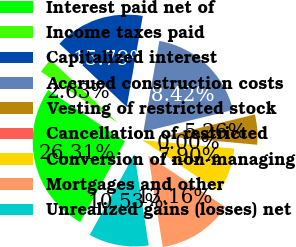<chart> <loc_0><loc_0><loc_500><loc_500><pie_chart><fcel>Interest paid net of<fcel>Income taxes paid<fcel>Capitalized interest<fcel>Accrued construction costs<fcel>Vesting of restricted stock<fcel>Cancellation of restricted<fcel>Conversion of non-managing<fcel>Mortgages and other<fcel>Unrealized gains (losses) net<nl><fcel>26.31%<fcel>2.63%<fcel>15.79%<fcel>18.42%<fcel>5.26%<fcel>0.0%<fcel>7.9%<fcel>13.16%<fcel>10.53%<nl></chart> 